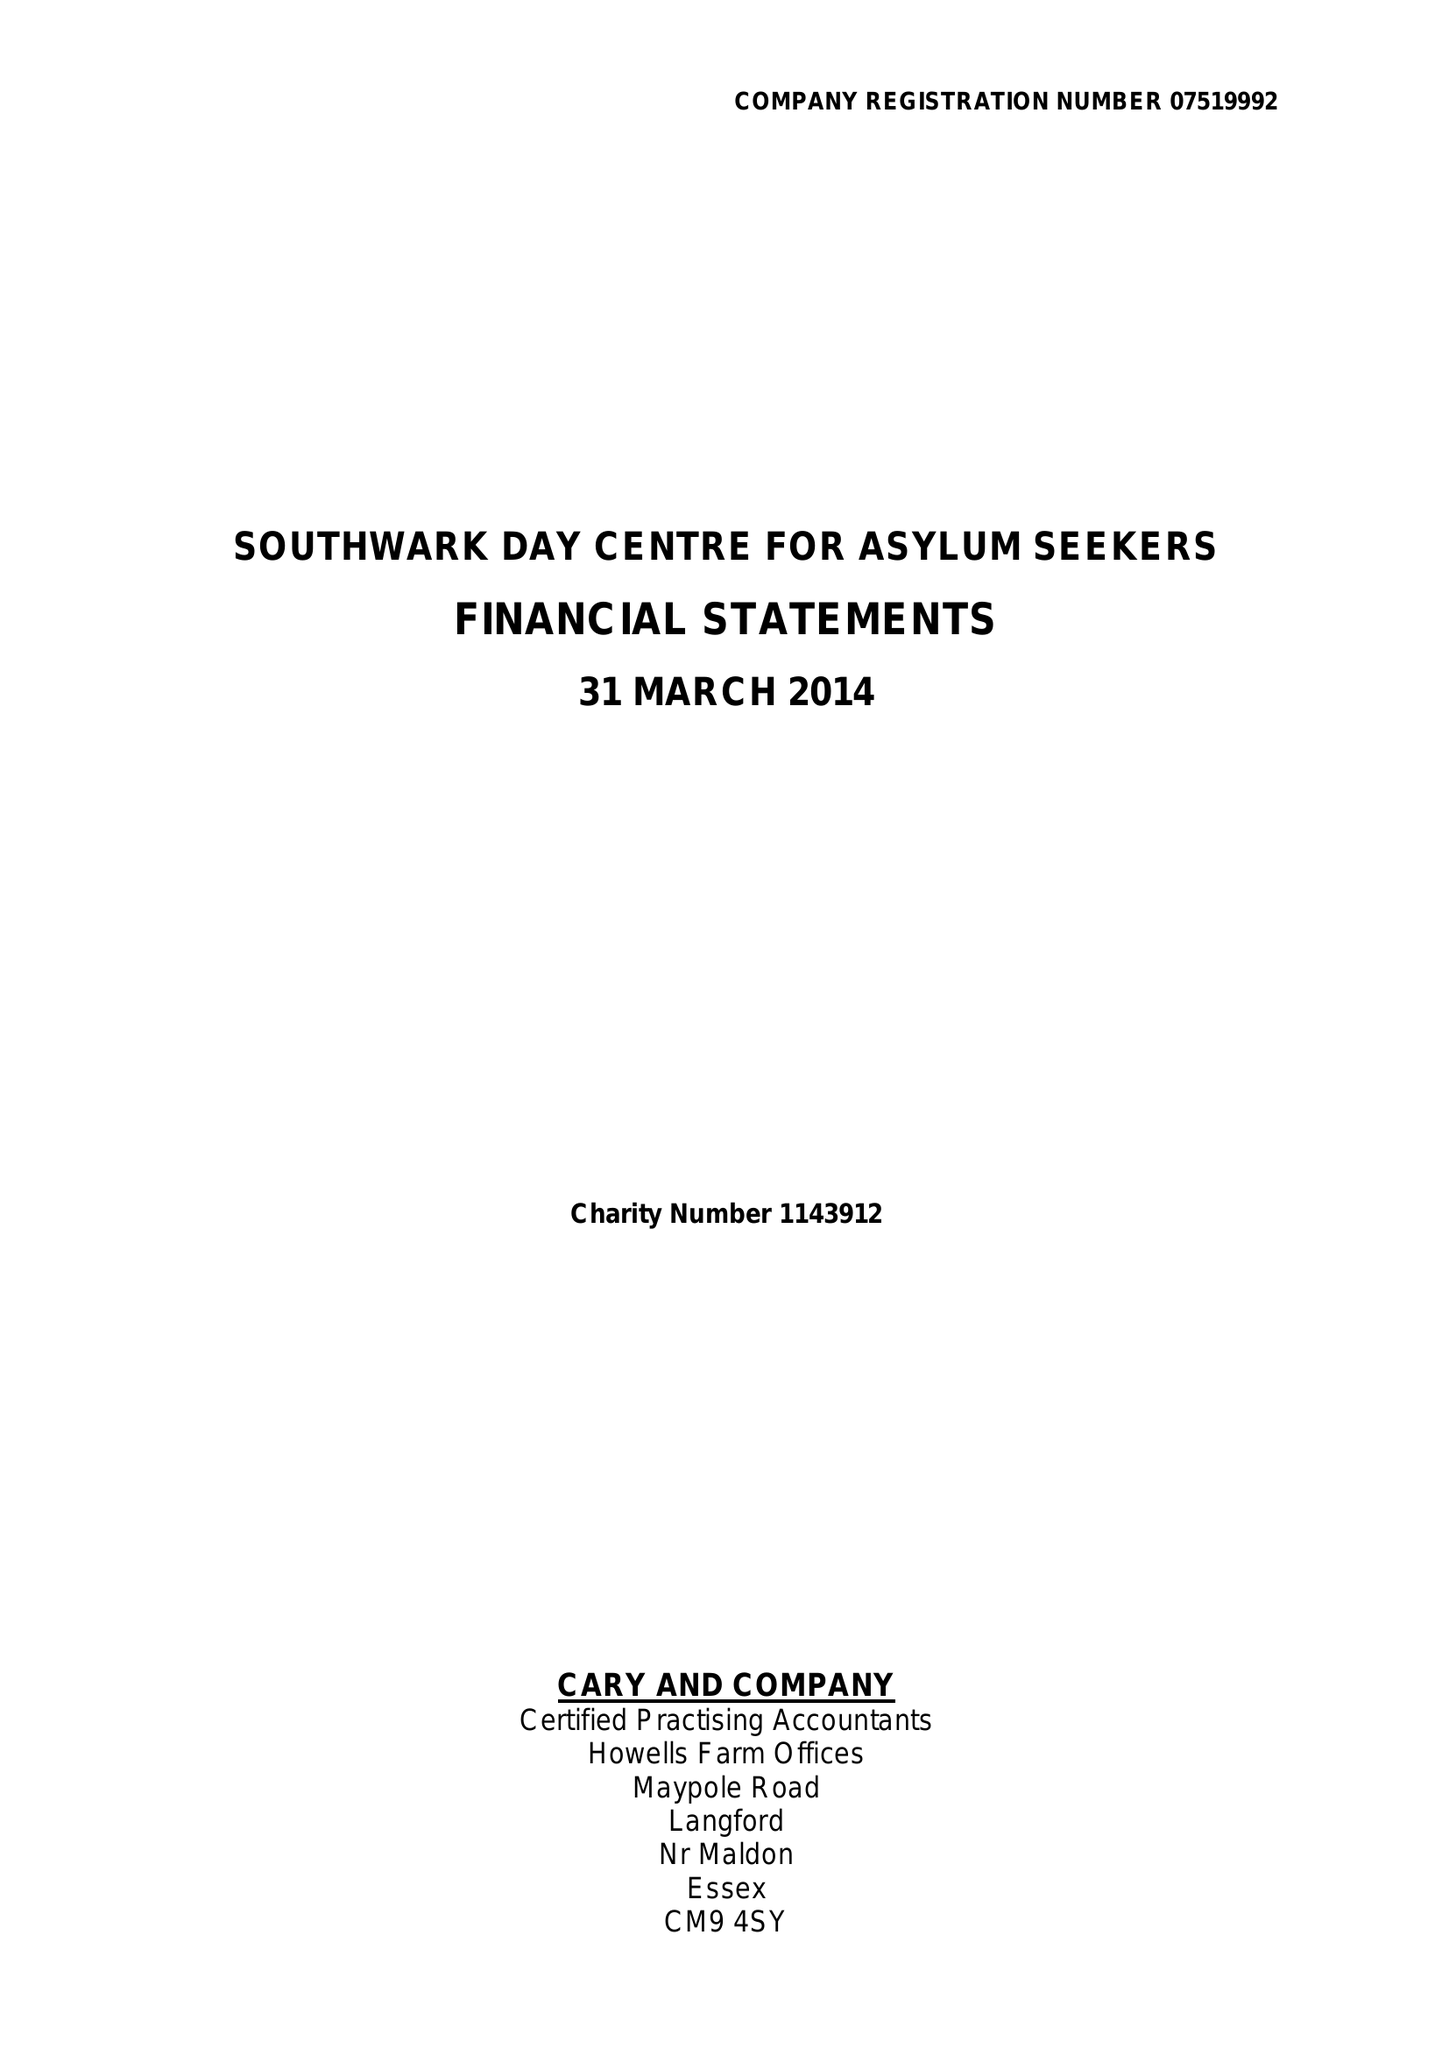What is the value for the report_date?
Answer the question using a single word or phrase. 2014-03-31 